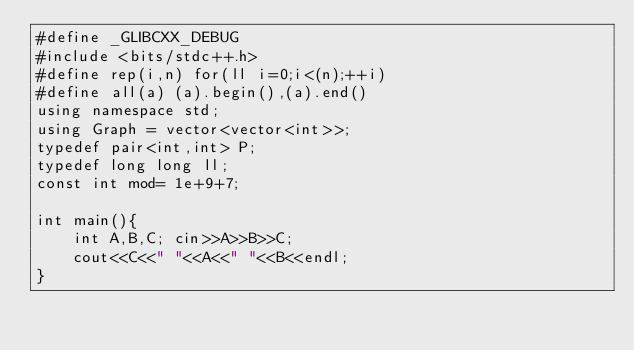<code> <loc_0><loc_0><loc_500><loc_500><_C++_>#define _GLIBCXX_DEBUG
#include <bits/stdc++.h>
#define rep(i,n) for(ll i=0;i<(n);++i)
#define all(a) (a).begin(),(a).end()
using namespace std;
using Graph = vector<vector<int>>;
typedef pair<int,int> P;
typedef long long ll;
const int mod= 1e+9+7;

int main(){
    int A,B,C; cin>>A>>B>>C;
    cout<<C<<" "<<A<<" "<<B<<endl;
}
</code> 